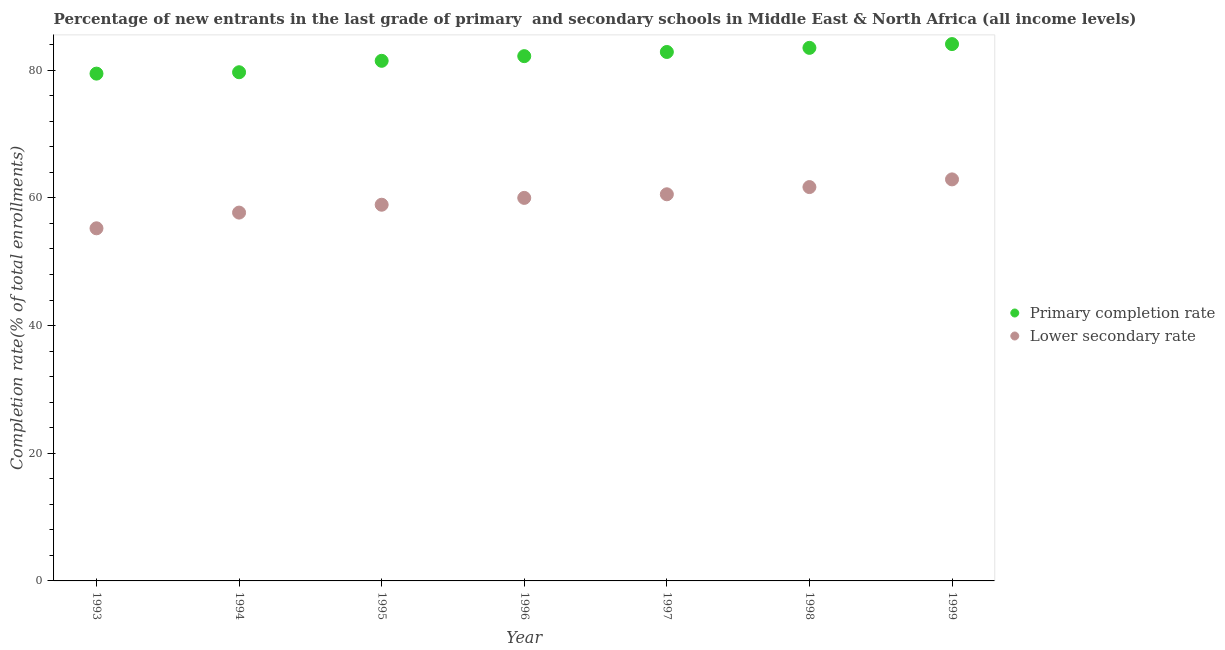What is the completion rate in primary schools in 1998?
Your answer should be compact. 83.49. Across all years, what is the maximum completion rate in primary schools?
Your answer should be compact. 84.08. Across all years, what is the minimum completion rate in primary schools?
Your answer should be compact. 79.46. In which year was the completion rate in primary schools maximum?
Your response must be concise. 1999. What is the total completion rate in primary schools in the graph?
Offer a terse response. 573.22. What is the difference between the completion rate in primary schools in 1998 and that in 1999?
Offer a very short reply. -0.59. What is the difference between the completion rate in secondary schools in 1997 and the completion rate in primary schools in 1996?
Make the answer very short. -21.64. What is the average completion rate in primary schools per year?
Provide a short and direct response. 81.89. In the year 1997, what is the difference between the completion rate in primary schools and completion rate in secondary schools?
Give a very brief answer. 22.29. In how many years, is the completion rate in primary schools greater than 64 %?
Offer a terse response. 7. What is the ratio of the completion rate in secondary schools in 1995 to that in 1999?
Provide a short and direct response. 0.94. Is the completion rate in secondary schools in 1994 less than that in 1997?
Provide a succinct answer. Yes. What is the difference between the highest and the second highest completion rate in primary schools?
Ensure brevity in your answer.  0.59. What is the difference between the highest and the lowest completion rate in primary schools?
Your answer should be very brief. 4.63. How many years are there in the graph?
Provide a succinct answer. 7. Does the graph contain any zero values?
Make the answer very short. No. Where does the legend appear in the graph?
Provide a succinct answer. Center right. What is the title of the graph?
Keep it short and to the point. Percentage of new entrants in the last grade of primary  and secondary schools in Middle East & North Africa (all income levels). What is the label or title of the X-axis?
Provide a succinct answer. Year. What is the label or title of the Y-axis?
Provide a short and direct response. Completion rate(% of total enrollments). What is the Completion rate(% of total enrollments) of Primary completion rate in 1993?
Give a very brief answer. 79.46. What is the Completion rate(% of total enrollments) in Lower secondary rate in 1993?
Make the answer very short. 55.23. What is the Completion rate(% of total enrollments) of Primary completion rate in 1994?
Keep it short and to the point. 79.67. What is the Completion rate(% of total enrollments) of Lower secondary rate in 1994?
Your response must be concise. 57.69. What is the Completion rate(% of total enrollments) in Primary completion rate in 1995?
Your answer should be compact. 81.46. What is the Completion rate(% of total enrollments) in Lower secondary rate in 1995?
Offer a very short reply. 58.92. What is the Completion rate(% of total enrollments) in Primary completion rate in 1996?
Provide a succinct answer. 82.19. What is the Completion rate(% of total enrollments) of Lower secondary rate in 1996?
Give a very brief answer. 59.99. What is the Completion rate(% of total enrollments) of Primary completion rate in 1997?
Make the answer very short. 82.85. What is the Completion rate(% of total enrollments) of Lower secondary rate in 1997?
Your answer should be compact. 60.56. What is the Completion rate(% of total enrollments) of Primary completion rate in 1998?
Your answer should be very brief. 83.49. What is the Completion rate(% of total enrollments) in Lower secondary rate in 1998?
Your answer should be very brief. 61.69. What is the Completion rate(% of total enrollments) in Primary completion rate in 1999?
Provide a short and direct response. 84.08. What is the Completion rate(% of total enrollments) of Lower secondary rate in 1999?
Your answer should be compact. 62.89. Across all years, what is the maximum Completion rate(% of total enrollments) of Primary completion rate?
Offer a very short reply. 84.08. Across all years, what is the maximum Completion rate(% of total enrollments) of Lower secondary rate?
Offer a terse response. 62.89. Across all years, what is the minimum Completion rate(% of total enrollments) of Primary completion rate?
Make the answer very short. 79.46. Across all years, what is the minimum Completion rate(% of total enrollments) of Lower secondary rate?
Keep it short and to the point. 55.23. What is the total Completion rate(% of total enrollments) in Primary completion rate in the graph?
Your response must be concise. 573.22. What is the total Completion rate(% of total enrollments) of Lower secondary rate in the graph?
Offer a terse response. 416.98. What is the difference between the Completion rate(% of total enrollments) in Primary completion rate in 1993 and that in 1994?
Your response must be concise. -0.21. What is the difference between the Completion rate(% of total enrollments) in Lower secondary rate in 1993 and that in 1994?
Offer a terse response. -2.46. What is the difference between the Completion rate(% of total enrollments) of Primary completion rate in 1993 and that in 1995?
Offer a very short reply. -2. What is the difference between the Completion rate(% of total enrollments) in Lower secondary rate in 1993 and that in 1995?
Your answer should be compact. -3.69. What is the difference between the Completion rate(% of total enrollments) of Primary completion rate in 1993 and that in 1996?
Offer a very short reply. -2.74. What is the difference between the Completion rate(% of total enrollments) of Lower secondary rate in 1993 and that in 1996?
Offer a very short reply. -4.76. What is the difference between the Completion rate(% of total enrollments) of Primary completion rate in 1993 and that in 1997?
Your response must be concise. -3.39. What is the difference between the Completion rate(% of total enrollments) of Lower secondary rate in 1993 and that in 1997?
Ensure brevity in your answer.  -5.33. What is the difference between the Completion rate(% of total enrollments) in Primary completion rate in 1993 and that in 1998?
Your response must be concise. -4.03. What is the difference between the Completion rate(% of total enrollments) of Lower secondary rate in 1993 and that in 1998?
Provide a short and direct response. -6.46. What is the difference between the Completion rate(% of total enrollments) of Primary completion rate in 1993 and that in 1999?
Make the answer very short. -4.63. What is the difference between the Completion rate(% of total enrollments) in Lower secondary rate in 1993 and that in 1999?
Provide a short and direct response. -7.66. What is the difference between the Completion rate(% of total enrollments) in Primary completion rate in 1994 and that in 1995?
Give a very brief answer. -1.79. What is the difference between the Completion rate(% of total enrollments) in Lower secondary rate in 1994 and that in 1995?
Ensure brevity in your answer.  -1.23. What is the difference between the Completion rate(% of total enrollments) of Primary completion rate in 1994 and that in 1996?
Your response must be concise. -2.52. What is the difference between the Completion rate(% of total enrollments) in Lower secondary rate in 1994 and that in 1996?
Give a very brief answer. -2.3. What is the difference between the Completion rate(% of total enrollments) in Primary completion rate in 1994 and that in 1997?
Offer a very short reply. -3.18. What is the difference between the Completion rate(% of total enrollments) in Lower secondary rate in 1994 and that in 1997?
Your answer should be compact. -2.87. What is the difference between the Completion rate(% of total enrollments) in Primary completion rate in 1994 and that in 1998?
Ensure brevity in your answer.  -3.82. What is the difference between the Completion rate(% of total enrollments) of Lower secondary rate in 1994 and that in 1998?
Your answer should be compact. -4. What is the difference between the Completion rate(% of total enrollments) in Primary completion rate in 1994 and that in 1999?
Your answer should be very brief. -4.41. What is the difference between the Completion rate(% of total enrollments) of Lower secondary rate in 1994 and that in 1999?
Offer a very short reply. -5.2. What is the difference between the Completion rate(% of total enrollments) of Primary completion rate in 1995 and that in 1996?
Offer a very short reply. -0.73. What is the difference between the Completion rate(% of total enrollments) of Lower secondary rate in 1995 and that in 1996?
Your answer should be compact. -1.07. What is the difference between the Completion rate(% of total enrollments) in Primary completion rate in 1995 and that in 1997?
Offer a very short reply. -1.39. What is the difference between the Completion rate(% of total enrollments) in Lower secondary rate in 1995 and that in 1997?
Provide a short and direct response. -1.63. What is the difference between the Completion rate(% of total enrollments) in Primary completion rate in 1995 and that in 1998?
Provide a short and direct response. -2.03. What is the difference between the Completion rate(% of total enrollments) of Lower secondary rate in 1995 and that in 1998?
Make the answer very short. -2.77. What is the difference between the Completion rate(% of total enrollments) in Primary completion rate in 1995 and that in 1999?
Your response must be concise. -2.62. What is the difference between the Completion rate(% of total enrollments) of Lower secondary rate in 1995 and that in 1999?
Ensure brevity in your answer.  -3.97. What is the difference between the Completion rate(% of total enrollments) of Primary completion rate in 1996 and that in 1997?
Your response must be concise. -0.65. What is the difference between the Completion rate(% of total enrollments) of Lower secondary rate in 1996 and that in 1997?
Offer a very short reply. -0.56. What is the difference between the Completion rate(% of total enrollments) of Primary completion rate in 1996 and that in 1998?
Give a very brief answer. -1.3. What is the difference between the Completion rate(% of total enrollments) of Lower secondary rate in 1996 and that in 1998?
Your answer should be very brief. -1.7. What is the difference between the Completion rate(% of total enrollments) of Primary completion rate in 1996 and that in 1999?
Your answer should be compact. -1.89. What is the difference between the Completion rate(% of total enrollments) in Lower secondary rate in 1996 and that in 1999?
Your answer should be compact. -2.9. What is the difference between the Completion rate(% of total enrollments) of Primary completion rate in 1997 and that in 1998?
Your response must be concise. -0.64. What is the difference between the Completion rate(% of total enrollments) of Lower secondary rate in 1997 and that in 1998?
Make the answer very short. -1.13. What is the difference between the Completion rate(% of total enrollments) in Primary completion rate in 1997 and that in 1999?
Your answer should be compact. -1.24. What is the difference between the Completion rate(% of total enrollments) in Lower secondary rate in 1997 and that in 1999?
Your answer should be very brief. -2.33. What is the difference between the Completion rate(% of total enrollments) of Primary completion rate in 1998 and that in 1999?
Ensure brevity in your answer.  -0.59. What is the difference between the Completion rate(% of total enrollments) in Lower secondary rate in 1998 and that in 1999?
Provide a short and direct response. -1.2. What is the difference between the Completion rate(% of total enrollments) of Primary completion rate in 1993 and the Completion rate(% of total enrollments) of Lower secondary rate in 1994?
Your answer should be very brief. 21.77. What is the difference between the Completion rate(% of total enrollments) in Primary completion rate in 1993 and the Completion rate(% of total enrollments) in Lower secondary rate in 1995?
Provide a short and direct response. 20.53. What is the difference between the Completion rate(% of total enrollments) of Primary completion rate in 1993 and the Completion rate(% of total enrollments) of Lower secondary rate in 1996?
Offer a terse response. 19.46. What is the difference between the Completion rate(% of total enrollments) of Primary completion rate in 1993 and the Completion rate(% of total enrollments) of Lower secondary rate in 1997?
Your response must be concise. 18.9. What is the difference between the Completion rate(% of total enrollments) in Primary completion rate in 1993 and the Completion rate(% of total enrollments) in Lower secondary rate in 1998?
Provide a short and direct response. 17.77. What is the difference between the Completion rate(% of total enrollments) of Primary completion rate in 1993 and the Completion rate(% of total enrollments) of Lower secondary rate in 1999?
Make the answer very short. 16.57. What is the difference between the Completion rate(% of total enrollments) of Primary completion rate in 1994 and the Completion rate(% of total enrollments) of Lower secondary rate in 1995?
Keep it short and to the point. 20.75. What is the difference between the Completion rate(% of total enrollments) of Primary completion rate in 1994 and the Completion rate(% of total enrollments) of Lower secondary rate in 1996?
Your response must be concise. 19.68. What is the difference between the Completion rate(% of total enrollments) in Primary completion rate in 1994 and the Completion rate(% of total enrollments) in Lower secondary rate in 1997?
Your response must be concise. 19.12. What is the difference between the Completion rate(% of total enrollments) in Primary completion rate in 1994 and the Completion rate(% of total enrollments) in Lower secondary rate in 1998?
Offer a very short reply. 17.98. What is the difference between the Completion rate(% of total enrollments) of Primary completion rate in 1994 and the Completion rate(% of total enrollments) of Lower secondary rate in 1999?
Offer a very short reply. 16.78. What is the difference between the Completion rate(% of total enrollments) in Primary completion rate in 1995 and the Completion rate(% of total enrollments) in Lower secondary rate in 1996?
Give a very brief answer. 21.47. What is the difference between the Completion rate(% of total enrollments) of Primary completion rate in 1995 and the Completion rate(% of total enrollments) of Lower secondary rate in 1997?
Your answer should be compact. 20.91. What is the difference between the Completion rate(% of total enrollments) of Primary completion rate in 1995 and the Completion rate(% of total enrollments) of Lower secondary rate in 1998?
Your answer should be compact. 19.77. What is the difference between the Completion rate(% of total enrollments) in Primary completion rate in 1995 and the Completion rate(% of total enrollments) in Lower secondary rate in 1999?
Your response must be concise. 18.57. What is the difference between the Completion rate(% of total enrollments) of Primary completion rate in 1996 and the Completion rate(% of total enrollments) of Lower secondary rate in 1997?
Make the answer very short. 21.64. What is the difference between the Completion rate(% of total enrollments) of Primary completion rate in 1996 and the Completion rate(% of total enrollments) of Lower secondary rate in 1998?
Provide a short and direct response. 20.51. What is the difference between the Completion rate(% of total enrollments) in Primary completion rate in 1996 and the Completion rate(% of total enrollments) in Lower secondary rate in 1999?
Ensure brevity in your answer.  19.3. What is the difference between the Completion rate(% of total enrollments) in Primary completion rate in 1997 and the Completion rate(% of total enrollments) in Lower secondary rate in 1998?
Make the answer very short. 21.16. What is the difference between the Completion rate(% of total enrollments) of Primary completion rate in 1997 and the Completion rate(% of total enrollments) of Lower secondary rate in 1999?
Offer a terse response. 19.96. What is the difference between the Completion rate(% of total enrollments) of Primary completion rate in 1998 and the Completion rate(% of total enrollments) of Lower secondary rate in 1999?
Provide a succinct answer. 20.6. What is the average Completion rate(% of total enrollments) of Primary completion rate per year?
Provide a succinct answer. 81.89. What is the average Completion rate(% of total enrollments) of Lower secondary rate per year?
Give a very brief answer. 59.57. In the year 1993, what is the difference between the Completion rate(% of total enrollments) in Primary completion rate and Completion rate(% of total enrollments) in Lower secondary rate?
Give a very brief answer. 24.23. In the year 1994, what is the difference between the Completion rate(% of total enrollments) in Primary completion rate and Completion rate(% of total enrollments) in Lower secondary rate?
Give a very brief answer. 21.98. In the year 1995, what is the difference between the Completion rate(% of total enrollments) of Primary completion rate and Completion rate(% of total enrollments) of Lower secondary rate?
Make the answer very short. 22.54. In the year 1996, what is the difference between the Completion rate(% of total enrollments) in Primary completion rate and Completion rate(% of total enrollments) in Lower secondary rate?
Offer a very short reply. 22.2. In the year 1997, what is the difference between the Completion rate(% of total enrollments) of Primary completion rate and Completion rate(% of total enrollments) of Lower secondary rate?
Give a very brief answer. 22.29. In the year 1998, what is the difference between the Completion rate(% of total enrollments) of Primary completion rate and Completion rate(% of total enrollments) of Lower secondary rate?
Provide a short and direct response. 21.8. In the year 1999, what is the difference between the Completion rate(% of total enrollments) of Primary completion rate and Completion rate(% of total enrollments) of Lower secondary rate?
Ensure brevity in your answer.  21.19. What is the ratio of the Completion rate(% of total enrollments) of Lower secondary rate in 1993 to that in 1994?
Provide a short and direct response. 0.96. What is the ratio of the Completion rate(% of total enrollments) in Primary completion rate in 1993 to that in 1995?
Provide a short and direct response. 0.98. What is the ratio of the Completion rate(% of total enrollments) of Lower secondary rate in 1993 to that in 1995?
Give a very brief answer. 0.94. What is the ratio of the Completion rate(% of total enrollments) in Primary completion rate in 1993 to that in 1996?
Ensure brevity in your answer.  0.97. What is the ratio of the Completion rate(% of total enrollments) in Lower secondary rate in 1993 to that in 1996?
Your answer should be compact. 0.92. What is the ratio of the Completion rate(% of total enrollments) of Primary completion rate in 1993 to that in 1997?
Offer a terse response. 0.96. What is the ratio of the Completion rate(% of total enrollments) in Lower secondary rate in 1993 to that in 1997?
Provide a succinct answer. 0.91. What is the ratio of the Completion rate(% of total enrollments) in Primary completion rate in 1993 to that in 1998?
Ensure brevity in your answer.  0.95. What is the ratio of the Completion rate(% of total enrollments) of Lower secondary rate in 1993 to that in 1998?
Your response must be concise. 0.9. What is the ratio of the Completion rate(% of total enrollments) in Primary completion rate in 1993 to that in 1999?
Your answer should be compact. 0.94. What is the ratio of the Completion rate(% of total enrollments) of Lower secondary rate in 1993 to that in 1999?
Ensure brevity in your answer.  0.88. What is the ratio of the Completion rate(% of total enrollments) in Primary completion rate in 1994 to that in 1995?
Give a very brief answer. 0.98. What is the ratio of the Completion rate(% of total enrollments) in Lower secondary rate in 1994 to that in 1995?
Offer a terse response. 0.98. What is the ratio of the Completion rate(% of total enrollments) of Primary completion rate in 1994 to that in 1996?
Give a very brief answer. 0.97. What is the ratio of the Completion rate(% of total enrollments) in Lower secondary rate in 1994 to that in 1996?
Make the answer very short. 0.96. What is the ratio of the Completion rate(% of total enrollments) of Primary completion rate in 1994 to that in 1997?
Your response must be concise. 0.96. What is the ratio of the Completion rate(% of total enrollments) in Lower secondary rate in 1994 to that in 1997?
Keep it short and to the point. 0.95. What is the ratio of the Completion rate(% of total enrollments) in Primary completion rate in 1994 to that in 1998?
Offer a terse response. 0.95. What is the ratio of the Completion rate(% of total enrollments) in Lower secondary rate in 1994 to that in 1998?
Offer a terse response. 0.94. What is the ratio of the Completion rate(% of total enrollments) in Primary completion rate in 1994 to that in 1999?
Your answer should be very brief. 0.95. What is the ratio of the Completion rate(% of total enrollments) of Lower secondary rate in 1994 to that in 1999?
Your answer should be compact. 0.92. What is the ratio of the Completion rate(% of total enrollments) of Primary completion rate in 1995 to that in 1996?
Provide a short and direct response. 0.99. What is the ratio of the Completion rate(% of total enrollments) in Lower secondary rate in 1995 to that in 1996?
Offer a terse response. 0.98. What is the ratio of the Completion rate(% of total enrollments) in Primary completion rate in 1995 to that in 1997?
Offer a terse response. 0.98. What is the ratio of the Completion rate(% of total enrollments) of Lower secondary rate in 1995 to that in 1997?
Give a very brief answer. 0.97. What is the ratio of the Completion rate(% of total enrollments) in Primary completion rate in 1995 to that in 1998?
Ensure brevity in your answer.  0.98. What is the ratio of the Completion rate(% of total enrollments) of Lower secondary rate in 1995 to that in 1998?
Your response must be concise. 0.96. What is the ratio of the Completion rate(% of total enrollments) in Primary completion rate in 1995 to that in 1999?
Ensure brevity in your answer.  0.97. What is the ratio of the Completion rate(% of total enrollments) in Lower secondary rate in 1995 to that in 1999?
Ensure brevity in your answer.  0.94. What is the ratio of the Completion rate(% of total enrollments) in Primary completion rate in 1996 to that in 1997?
Provide a short and direct response. 0.99. What is the ratio of the Completion rate(% of total enrollments) in Primary completion rate in 1996 to that in 1998?
Your response must be concise. 0.98. What is the ratio of the Completion rate(% of total enrollments) of Lower secondary rate in 1996 to that in 1998?
Provide a succinct answer. 0.97. What is the ratio of the Completion rate(% of total enrollments) in Primary completion rate in 1996 to that in 1999?
Offer a very short reply. 0.98. What is the ratio of the Completion rate(% of total enrollments) of Lower secondary rate in 1996 to that in 1999?
Provide a succinct answer. 0.95. What is the ratio of the Completion rate(% of total enrollments) in Primary completion rate in 1997 to that in 1998?
Your answer should be compact. 0.99. What is the ratio of the Completion rate(% of total enrollments) of Lower secondary rate in 1997 to that in 1998?
Provide a succinct answer. 0.98. What is the ratio of the Completion rate(% of total enrollments) of Lower secondary rate in 1997 to that in 1999?
Ensure brevity in your answer.  0.96. What is the ratio of the Completion rate(% of total enrollments) of Primary completion rate in 1998 to that in 1999?
Make the answer very short. 0.99. What is the ratio of the Completion rate(% of total enrollments) in Lower secondary rate in 1998 to that in 1999?
Give a very brief answer. 0.98. What is the difference between the highest and the second highest Completion rate(% of total enrollments) of Primary completion rate?
Offer a very short reply. 0.59. What is the difference between the highest and the second highest Completion rate(% of total enrollments) of Lower secondary rate?
Provide a succinct answer. 1.2. What is the difference between the highest and the lowest Completion rate(% of total enrollments) in Primary completion rate?
Your response must be concise. 4.63. What is the difference between the highest and the lowest Completion rate(% of total enrollments) in Lower secondary rate?
Give a very brief answer. 7.66. 